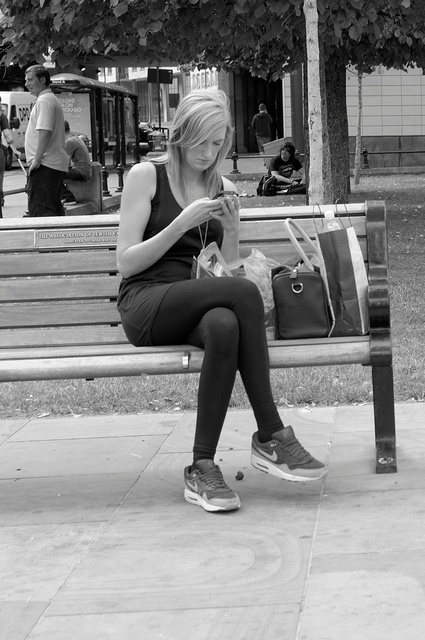Describe the objects in this image and their specific colors. I can see bench in gray, darkgray, black, and lightgray tones, people in gray, black, darkgray, and lightgray tones, people in gray, black, darkgray, and lightgray tones, handbag in gray, black, darkgray, and lightgray tones, and handbag in gray, black, lightgray, and darkgray tones in this image. 